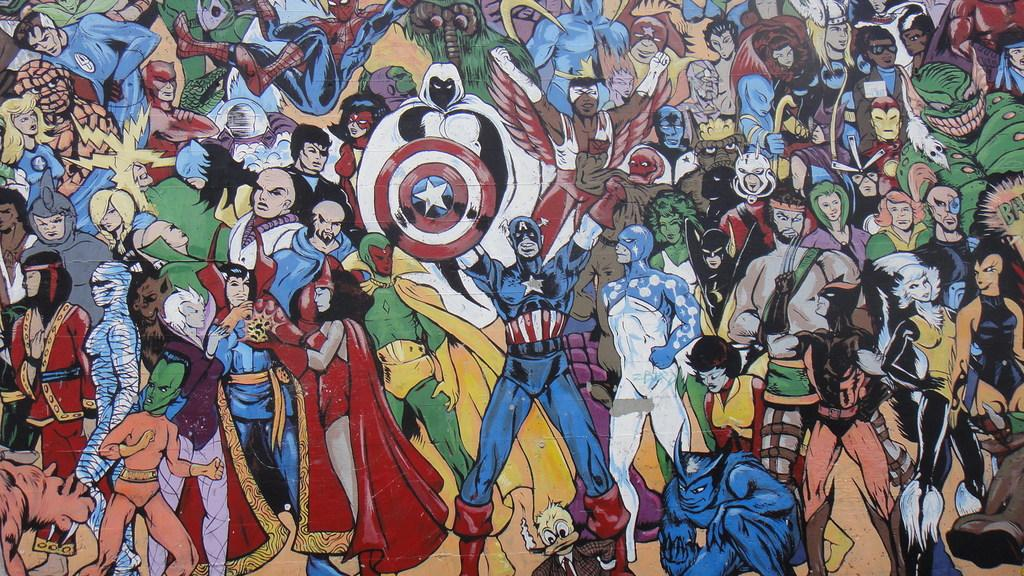What type of pictures are in the image? There are cartoon pictures in the image. What kind of subjects are depicted in the cartoon pictures? Animals are present in the cartoon pictures. Can you identify any specific animals in the cartoon pictures? Birds are present in the cartoon pictures. How are the cartoon pictures presented in the image? The cartoon pictures are in multiple colors. What type of discussion is taking place between the animals in the image? There is no discussion taking place between the animals in the image, as they are cartoon pictures and not real animals. 